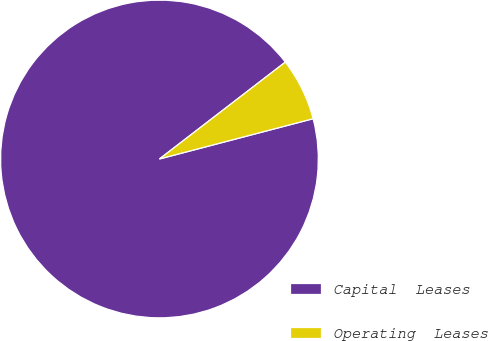Convert chart to OTSL. <chart><loc_0><loc_0><loc_500><loc_500><pie_chart><fcel>Capital  Leases<fcel>Operating  Leases<nl><fcel>93.64%<fcel>6.36%<nl></chart> 